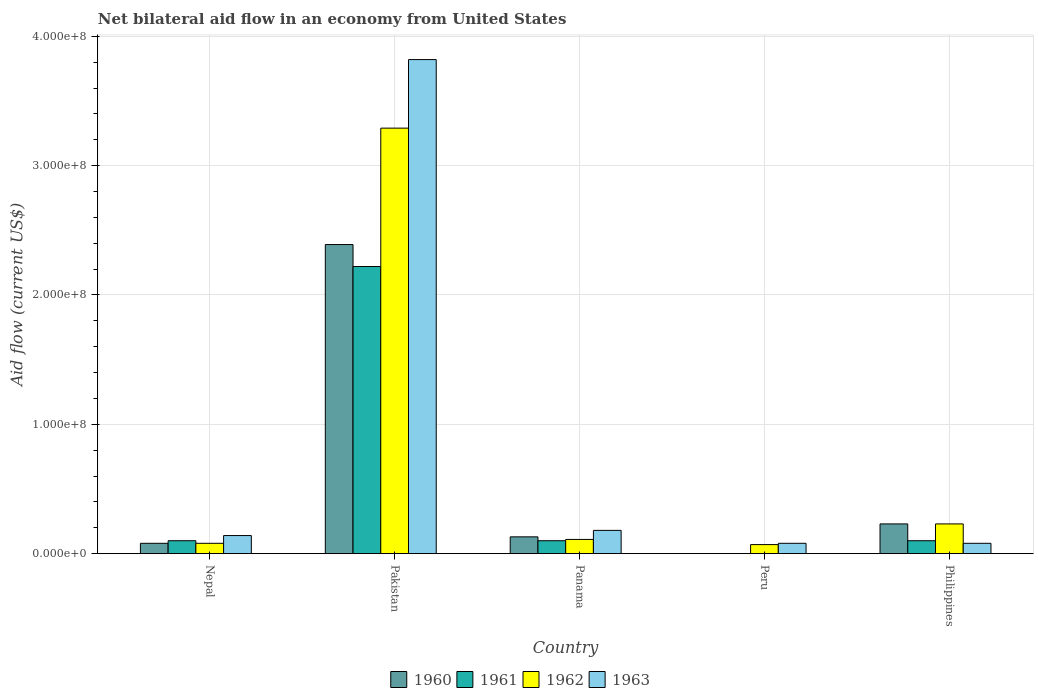How many different coloured bars are there?
Make the answer very short. 4. How many groups of bars are there?
Offer a very short reply. 5. What is the label of the 5th group of bars from the left?
Offer a terse response. Philippines. In how many cases, is the number of bars for a given country not equal to the number of legend labels?
Offer a terse response. 1. Across all countries, what is the maximum net bilateral aid flow in 1961?
Ensure brevity in your answer.  2.22e+08. Across all countries, what is the minimum net bilateral aid flow in 1960?
Offer a terse response. 0. What is the total net bilateral aid flow in 1963 in the graph?
Keep it short and to the point. 4.30e+08. What is the average net bilateral aid flow in 1962 per country?
Give a very brief answer. 7.56e+07. What is the ratio of the net bilateral aid flow in 1963 in Panama to that in Peru?
Your answer should be compact. 2.25. What is the difference between the highest and the second highest net bilateral aid flow in 1961?
Your response must be concise. 2.12e+08. What is the difference between the highest and the lowest net bilateral aid flow in 1962?
Your answer should be very brief. 3.22e+08. In how many countries, is the net bilateral aid flow in 1962 greater than the average net bilateral aid flow in 1962 taken over all countries?
Offer a terse response. 1. Is the sum of the net bilateral aid flow in 1960 in Pakistan and Philippines greater than the maximum net bilateral aid flow in 1962 across all countries?
Offer a very short reply. No. Are the values on the major ticks of Y-axis written in scientific E-notation?
Your answer should be compact. Yes. Does the graph contain any zero values?
Offer a very short reply. Yes. Where does the legend appear in the graph?
Offer a very short reply. Bottom center. How many legend labels are there?
Provide a short and direct response. 4. What is the title of the graph?
Your answer should be very brief. Net bilateral aid flow in an economy from United States. What is the Aid flow (current US$) in 1961 in Nepal?
Provide a short and direct response. 1.00e+07. What is the Aid flow (current US$) in 1962 in Nepal?
Give a very brief answer. 8.00e+06. What is the Aid flow (current US$) of 1963 in Nepal?
Offer a terse response. 1.40e+07. What is the Aid flow (current US$) of 1960 in Pakistan?
Give a very brief answer. 2.39e+08. What is the Aid flow (current US$) in 1961 in Pakistan?
Your answer should be compact. 2.22e+08. What is the Aid flow (current US$) in 1962 in Pakistan?
Your response must be concise. 3.29e+08. What is the Aid flow (current US$) in 1963 in Pakistan?
Ensure brevity in your answer.  3.82e+08. What is the Aid flow (current US$) of 1960 in Panama?
Your answer should be very brief. 1.30e+07. What is the Aid flow (current US$) in 1961 in Panama?
Your answer should be compact. 1.00e+07. What is the Aid flow (current US$) in 1962 in Panama?
Ensure brevity in your answer.  1.10e+07. What is the Aid flow (current US$) in 1963 in Panama?
Offer a very short reply. 1.80e+07. What is the Aid flow (current US$) of 1960 in Peru?
Your answer should be compact. 0. What is the Aid flow (current US$) of 1961 in Peru?
Your response must be concise. 0. What is the Aid flow (current US$) of 1962 in Peru?
Ensure brevity in your answer.  7.00e+06. What is the Aid flow (current US$) in 1960 in Philippines?
Your answer should be very brief. 2.30e+07. What is the Aid flow (current US$) of 1962 in Philippines?
Keep it short and to the point. 2.30e+07. Across all countries, what is the maximum Aid flow (current US$) of 1960?
Give a very brief answer. 2.39e+08. Across all countries, what is the maximum Aid flow (current US$) of 1961?
Offer a very short reply. 2.22e+08. Across all countries, what is the maximum Aid flow (current US$) in 1962?
Provide a short and direct response. 3.29e+08. Across all countries, what is the maximum Aid flow (current US$) of 1963?
Keep it short and to the point. 3.82e+08. Across all countries, what is the minimum Aid flow (current US$) in 1960?
Ensure brevity in your answer.  0. What is the total Aid flow (current US$) in 1960 in the graph?
Make the answer very short. 2.83e+08. What is the total Aid flow (current US$) in 1961 in the graph?
Your answer should be compact. 2.52e+08. What is the total Aid flow (current US$) of 1962 in the graph?
Keep it short and to the point. 3.78e+08. What is the total Aid flow (current US$) in 1963 in the graph?
Make the answer very short. 4.30e+08. What is the difference between the Aid flow (current US$) in 1960 in Nepal and that in Pakistan?
Keep it short and to the point. -2.31e+08. What is the difference between the Aid flow (current US$) of 1961 in Nepal and that in Pakistan?
Ensure brevity in your answer.  -2.12e+08. What is the difference between the Aid flow (current US$) in 1962 in Nepal and that in Pakistan?
Your answer should be very brief. -3.21e+08. What is the difference between the Aid flow (current US$) of 1963 in Nepal and that in Pakistan?
Offer a terse response. -3.68e+08. What is the difference between the Aid flow (current US$) of 1960 in Nepal and that in Panama?
Your answer should be very brief. -5.00e+06. What is the difference between the Aid flow (current US$) of 1963 in Nepal and that in Panama?
Offer a terse response. -4.00e+06. What is the difference between the Aid flow (current US$) of 1963 in Nepal and that in Peru?
Make the answer very short. 6.00e+06. What is the difference between the Aid flow (current US$) in 1960 in Nepal and that in Philippines?
Provide a succinct answer. -1.50e+07. What is the difference between the Aid flow (current US$) in 1962 in Nepal and that in Philippines?
Make the answer very short. -1.50e+07. What is the difference between the Aid flow (current US$) of 1963 in Nepal and that in Philippines?
Make the answer very short. 6.00e+06. What is the difference between the Aid flow (current US$) of 1960 in Pakistan and that in Panama?
Ensure brevity in your answer.  2.26e+08. What is the difference between the Aid flow (current US$) of 1961 in Pakistan and that in Panama?
Offer a terse response. 2.12e+08. What is the difference between the Aid flow (current US$) of 1962 in Pakistan and that in Panama?
Keep it short and to the point. 3.18e+08. What is the difference between the Aid flow (current US$) in 1963 in Pakistan and that in Panama?
Provide a succinct answer. 3.64e+08. What is the difference between the Aid flow (current US$) of 1962 in Pakistan and that in Peru?
Provide a short and direct response. 3.22e+08. What is the difference between the Aid flow (current US$) in 1963 in Pakistan and that in Peru?
Your answer should be compact. 3.74e+08. What is the difference between the Aid flow (current US$) in 1960 in Pakistan and that in Philippines?
Your response must be concise. 2.16e+08. What is the difference between the Aid flow (current US$) in 1961 in Pakistan and that in Philippines?
Your answer should be compact. 2.12e+08. What is the difference between the Aid flow (current US$) of 1962 in Pakistan and that in Philippines?
Provide a short and direct response. 3.06e+08. What is the difference between the Aid flow (current US$) of 1963 in Pakistan and that in Philippines?
Provide a succinct answer. 3.74e+08. What is the difference between the Aid flow (current US$) of 1962 in Panama and that in Peru?
Offer a very short reply. 4.00e+06. What is the difference between the Aid flow (current US$) in 1960 in Panama and that in Philippines?
Ensure brevity in your answer.  -1.00e+07. What is the difference between the Aid flow (current US$) in 1961 in Panama and that in Philippines?
Provide a succinct answer. 0. What is the difference between the Aid flow (current US$) in 1962 in Panama and that in Philippines?
Make the answer very short. -1.20e+07. What is the difference between the Aid flow (current US$) in 1963 in Panama and that in Philippines?
Offer a terse response. 1.00e+07. What is the difference between the Aid flow (current US$) in 1962 in Peru and that in Philippines?
Your answer should be very brief. -1.60e+07. What is the difference between the Aid flow (current US$) in 1963 in Peru and that in Philippines?
Provide a short and direct response. 0. What is the difference between the Aid flow (current US$) of 1960 in Nepal and the Aid flow (current US$) of 1961 in Pakistan?
Your answer should be compact. -2.14e+08. What is the difference between the Aid flow (current US$) in 1960 in Nepal and the Aid flow (current US$) in 1962 in Pakistan?
Offer a terse response. -3.21e+08. What is the difference between the Aid flow (current US$) in 1960 in Nepal and the Aid flow (current US$) in 1963 in Pakistan?
Make the answer very short. -3.74e+08. What is the difference between the Aid flow (current US$) in 1961 in Nepal and the Aid flow (current US$) in 1962 in Pakistan?
Provide a short and direct response. -3.19e+08. What is the difference between the Aid flow (current US$) of 1961 in Nepal and the Aid flow (current US$) of 1963 in Pakistan?
Your answer should be compact. -3.72e+08. What is the difference between the Aid flow (current US$) in 1962 in Nepal and the Aid flow (current US$) in 1963 in Pakistan?
Make the answer very short. -3.74e+08. What is the difference between the Aid flow (current US$) of 1960 in Nepal and the Aid flow (current US$) of 1961 in Panama?
Ensure brevity in your answer.  -2.00e+06. What is the difference between the Aid flow (current US$) of 1960 in Nepal and the Aid flow (current US$) of 1963 in Panama?
Your answer should be very brief. -1.00e+07. What is the difference between the Aid flow (current US$) in 1961 in Nepal and the Aid flow (current US$) in 1962 in Panama?
Keep it short and to the point. -1.00e+06. What is the difference between the Aid flow (current US$) of 1961 in Nepal and the Aid flow (current US$) of 1963 in Panama?
Offer a very short reply. -8.00e+06. What is the difference between the Aid flow (current US$) in 1962 in Nepal and the Aid flow (current US$) in 1963 in Panama?
Your response must be concise. -1.00e+07. What is the difference between the Aid flow (current US$) in 1960 in Nepal and the Aid flow (current US$) in 1963 in Peru?
Your answer should be very brief. 0. What is the difference between the Aid flow (current US$) in 1961 in Nepal and the Aid flow (current US$) in 1963 in Peru?
Ensure brevity in your answer.  2.00e+06. What is the difference between the Aid flow (current US$) of 1960 in Nepal and the Aid flow (current US$) of 1962 in Philippines?
Offer a terse response. -1.50e+07. What is the difference between the Aid flow (current US$) of 1961 in Nepal and the Aid flow (current US$) of 1962 in Philippines?
Offer a terse response. -1.30e+07. What is the difference between the Aid flow (current US$) in 1961 in Nepal and the Aid flow (current US$) in 1963 in Philippines?
Your answer should be compact. 2.00e+06. What is the difference between the Aid flow (current US$) in 1960 in Pakistan and the Aid flow (current US$) in 1961 in Panama?
Give a very brief answer. 2.29e+08. What is the difference between the Aid flow (current US$) in 1960 in Pakistan and the Aid flow (current US$) in 1962 in Panama?
Offer a terse response. 2.28e+08. What is the difference between the Aid flow (current US$) in 1960 in Pakistan and the Aid flow (current US$) in 1963 in Panama?
Your response must be concise. 2.21e+08. What is the difference between the Aid flow (current US$) in 1961 in Pakistan and the Aid flow (current US$) in 1962 in Panama?
Offer a very short reply. 2.11e+08. What is the difference between the Aid flow (current US$) of 1961 in Pakistan and the Aid flow (current US$) of 1963 in Panama?
Keep it short and to the point. 2.04e+08. What is the difference between the Aid flow (current US$) of 1962 in Pakistan and the Aid flow (current US$) of 1963 in Panama?
Offer a terse response. 3.11e+08. What is the difference between the Aid flow (current US$) in 1960 in Pakistan and the Aid flow (current US$) in 1962 in Peru?
Your answer should be very brief. 2.32e+08. What is the difference between the Aid flow (current US$) in 1960 in Pakistan and the Aid flow (current US$) in 1963 in Peru?
Your answer should be very brief. 2.31e+08. What is the difference between the Aid flow (current US$) of 1961 in Pakistan and the Aid flow (current US$) of 1962 in Peru?
Make the answer very short. 2.15e+08. What is the difference between the Aid flow (current US$) in 1961 in Pakistan and the Aid flow (current US$) in 1963 in Peru?
Ensure brevity in your answer.  2.14e+08. What is the difference between the Aid flow (current US$) in 1962 in Pakistan and the Aid flow (current US$) in 1963 in Peru?
Your answer should be very brief. 3.21e+08. What is the difference between the Aid flow (current US$) of 1960 in Pakistan and the Aid flow (current US$) of 1961 in Philippines?
Provide a succinct answer. 2.29e+08. What is the difference between the Aid flow (current US$) of 1960 in Pakistan and the Aid flow (current US$) of 1962 in Philippines?
Make the answer very short. 2.16e+08. What is the difference between the Aid flow (current US$) of 1960 in Pakistan and the Aid flow (current US$) of 1963 in Philippines?
Your answer should be compact. 2.31e+08. What is the difference between the Aid flow (current US$) in 1961 in Pakistan and the Aid flow (current US$) in 1962 in Philippines?
Keep it short and to the point. 1.99e+08. What is the difference between the Aid flow (current US$) of 1961 in Pakistan and the Aid flow (current US$) of 1963 in Philippines?
Keep it short and to the point. 2.14e+08. What is the difference between the Aid flow (current US$) of 1962 in Pakistan and the Aid flow (current US$) of 1963 in Philippines?
Offer a terse response. 3.21e+08. What is the difference between the Aid flow (current US$) of 1960 in Panama and the Aid flow (current US$) of 1962 in Peru?
Keep it short and to the point. 6.00e+06. What is the difference between the Aid flow (current US$) in 1960 in Panama and the Aid flow (current US$) in 1963 in Peru?
Give a very brief answer. 5.00e+06. What is the difference between the Aid flow (current US$) in 1961 in Panama and the Aid flow (current US$) in 1962 in Peru?
Offer a terse response. 3.00e+06. What is the difference between the Aid flow (current US$) of 1960 in Panama and the Aid flow (current US$) of 1961 in Philippines?
Offer a very short reply. 3.00e+06. What is the difference between the Aid flow (current US$) in 1960 in Panama and the Aid flow (current US$) in 1962 in Philippines?
Provide a short and direct response. -1.00e+07. What is the difference between the Aid flow (current US$) of 1961 in Panama and the Aid flow (current US$) of 1962 in Philippines?
Your answer should be very brief. -1.30e+07. What is the difference between the Aid flow (current US$) of 1961 in Panama and the Aid flow (current US$) of 1963 in Philippines?
Keep it short and to the point. 2.00e+06. What is the difference between the Aid flow (current US$) of 1962 in Panama and the Aid flow (current US$) of 1963 in Philippines?
Your response must be concise. 3.00e+06. What is the average Aid flow (current US$) of 1960 per country?
Your answer should be very brief. 5.66e+07. What is the average Aid flow (current US$) of 1961 per country?
Give a very brief answer. 5.04e+07. What is the average Aid flow (current US$) in 1962 per country?
Give a very brief answer. 7.56e+07. What is the average Aid flow (current US$) of 1963 per country?
Provide a succinct answer. 8.60e+07. What is the difference between the Aid flow (current US$) of 1960 and Aid flow (current US$) of 1961 in Nepal?
Provide a succinct answer. -2.00e+06. What is the difference between the Aid flow (current US$) in 1960 and Aid flow (current US$) in 1962 in Nepal?
Offer a terse response. 0. What is the difference between the Aid flow (current US$) of 1960 and Aid flow (current US$) of 1963 in Nepal?
Offer a very short reply. -6.00e+06. What is the difference between the Aid flow (current US$) of 1961 and Aid flow (current US$) of 1963 in Nepal?
Your answer should be compact. -4.00e+06. What is the difference between the Aid flow (current US$) of 1962 and Aid flow (current US$) of 1963 in Nepal?
Your response must be concise. -6.00e+06. What is the difference between the Aid flow (current US$) of 1960 and Aid flow (current US$) of 1961 in Pakistan?
Offer a very short reply. 1.70e+07. What is the difference between the Aid flow (current US$) in 1960 and Aid flow (current US$) in 1962 in Pakistan?
Ensure brevity in your answer.  -9.00e+07. What is the difference between the Aid flow (current US$) of 1960 and Aid flow (current US$) of 1963 in Pakistan?
Your response must be concise. -1.43e+08. What is the difference between the Aid flow (current US$) in 1961 and Aid flow (current US$) in 1962 in Pakistan?
Your answer should be compact. -1.07e+08. What is the difference between the Aid flow (current US$) in 1961 and Aid flow (current US$) in 1963 in Pakistan?
Give a very brief answer. -1.60e+08. What is the difference between the Aid flow (current US$) in 1962 and Aid flow (current US$) in 1963 in Pakistan?
Give a very brief answer. -5.30e+07. What is the difference between the Aid flow (current US$) of 1960 and Aid flow (current US$) of 1962 in Panama?
Your answer should be very brief. 2.00e+06. What is the difference between the Aid flow (current US$) of 1960 and Aid flow (current US$) of 1963 in Panama?
Offer a terse response. -5.00e+06. What is the difference between the Aid flow (current US$) of 1961 and Aid flow (current US$) of 1962 in Panama?
Provide a short and direct response. -1.00e+06. What is the difference between the Aid flow (current US$) in 1961 and Aid flow (current US$) in 1963 in Panama?
Make the answer very short. -8.00e+06. What is the difference between the Aid flow (current US$) in 1962 and Aid flow (current US$) in 1963 in Panama?
Make the answer very short. -7.00e+06. What is the difference between the Aid flow (current US$) of 1962 and Aid flow (current US$) of 1963 in Peru?
Ensure brevity in your answer.  -1.00e+06. What is the difference between the Aid flow (current US$) of 1960 and Aid flow (current US$) of 1961 in Philippines?
Provide a short and direct response. 1.30e+07. What is the difference between the Aid flow (current US$) in 1960 and Aid flow (current US$) in 1962 in Philippines?
Provide a succinct answer. 0. What is the difference between the Aid flow (current US$) in 1960 and Aid flow (current US$) in 1963 in Philippines?
Keep it short and to the point. 1.50e+07. What is the difference between the Aid flow (current US$) in 1961 and Aid flow (current US$) in 1962 in Philippines?
Offer a terse response. -1.30e+07. What is the difference between the Aid flow (current US$) in 1961 and Aid flow (current US$) in 1963 in Philippines?
Your answer should be compact. 2.00e+06. What is the difference between the Aid flow (current US$) of 1962 and Aid flow (current US$) of 1963 in Philippines?
Ensure brevity in your answer.  1.50e+07. What is the ratio of the Aid flow (current US$) of 1960 in Nepal to that in Pakistan?
Your response must be concise. 0.03. What is the ratio of the Aid flow (current US$) of 1961 in Nepal to that in Pakistan?
Your response must be concise. 0.04. What is the ratio of the Aid flow (current US$) in 1962 in Nepal to that in Pakistan?
Your answer should be compact. 0.02. What is the ratio of the Aid flow (current US$) in 1963 in Nepal to that in Pakistan?
Keep it short and to the point. 0.04. What is the ratio of the Aid flow (current US$) of 1960 in Nepal to that in Panama?
Ensure brevity in your answer.  0.62. What is the ratio of the Aid flow (current US$) of 1961 in Nepal to that in Panama?
Provide a succinct answer. 1. What is the ratio of the Aid flow (current US$) of 1962 in Nepal to that in Panama?
Make the answer very short. 0.73. What is the ratio of the Aid flow (current US$) of 1963 in Nepal to that in Panama?
Your response must be concise. 0.78. What is the ratio of the Aid flow (current US$) of 1963 in Nepal to that in Peru?
Your answer should be compact. 1.75. What is the ratio of the Aid flow (current US$) of 1960 in Nepal to that in Philippines?
Your answer should be compact. 0.35. What is the ratio of the Aid flow (current US$) in 1962 in Nepal to that in Philippines?
Offer a very short reply. 0.35. What is the ratio of the Aid flow (current US$) of 1960 in Pakistan to that in Panama?
Keep it short and to the point. 18.38. What is the ratio of the Aid flow (current US$) in 1962 in Pakistan to that in Panama?
Your answer should be compact. 29.91. What is the ratio of the Aid flow (current US$) in 1963 in Pakistan to that in Panama?
Offer a terse response. 21.22. What is the ratio of the Aid flow (current US$) in 1963 in Pakistan to that in Peru?
Your response must be concise. 47.75. What is the ratio of the Aid flow (current US$) of 1960 in Pakistan to that in Philippines?
Offer a very short reply. 10.39. What is the ratio of the Aid flow (current US$) in 1961 in Pakistan to that in Philippines?
Provide a succinct answer. 22.2. What is the ratio of the Aid flow (current US$) of 1962 in Pakistan to that in Philippines?
Provide a short and direct response. 14.3. What is the ratio of the Aid flow (current US$) of 1963 in Pakistan to that in Philippines?
Your answer should be very brief. 47.75. What is the ratio of the Aid flow (current US$) of 1962 in Panama to that in Peru?
Keep it short and to the point. 1.57. What is the ratio of the Aid flow (current US$) of 1963 in Panama to that in Peru?
Your answer should be compact. 2.25. What is the ratio of the Aid flow (current US$) of 1960 in Panama to that in Philippines?
Make the answer very short. 0.57. What is the ratio of the Aid flow (current US$) in 1961 in Panama to that in Philippines?
Your answer should be very brief. 1. What is the ratio of the Aid flow (current US$) of 1962 in Panama to that in Philippines?
Offer a very short reply. 0.48. What is the ratio of the Aid flow (current US$) in 1963 in Panama to that in Philippines?
Ensure brevity in your answer.  2.25. What is the ratio of the Aid flow (current US$) in 1962 in Peru to that in Philippines?
Offer a very short reply. 0.3. What is the ratio of the Aid flow (current US$) in 1963 in Peru to that in Philippines?
Your answer should be very brief. 1. What is the difference between the highest and the second highest Aid flow (current US$) in 1960?
Your answer should be very brief. 2.16e+08. What is the difference between the highest and the second highest Aid flow (current US$) in 1961?
Your response must be concise. 2.12e+08. What is the difference between the highest and the second highest Aid flow (current US$) in 1962?
Keep it short and to the point. 3.06e+08. What is the difference between the highest and the second highest Aid flow (current US$) in 1963?
Ensure brevity in your answer.  3.64e+08. What is the difference between the highest and the lowest Aid flow (current US$) in 1960?
Your answer should be compact. 2.39e+08. What is the difference between the highest and the lowest Aid flow (current US$) in 1961?
Your response must be concise. 2.22e+08. What is the difference between the highest and the lowest Aid flow (current US$) of 1962?
Keep it short and to the point. 3.22e+08. What is the difference between the highest and the lowest Aid flow (current US$) in 1963?
Provide a succinct answer. 3.74e+08. 